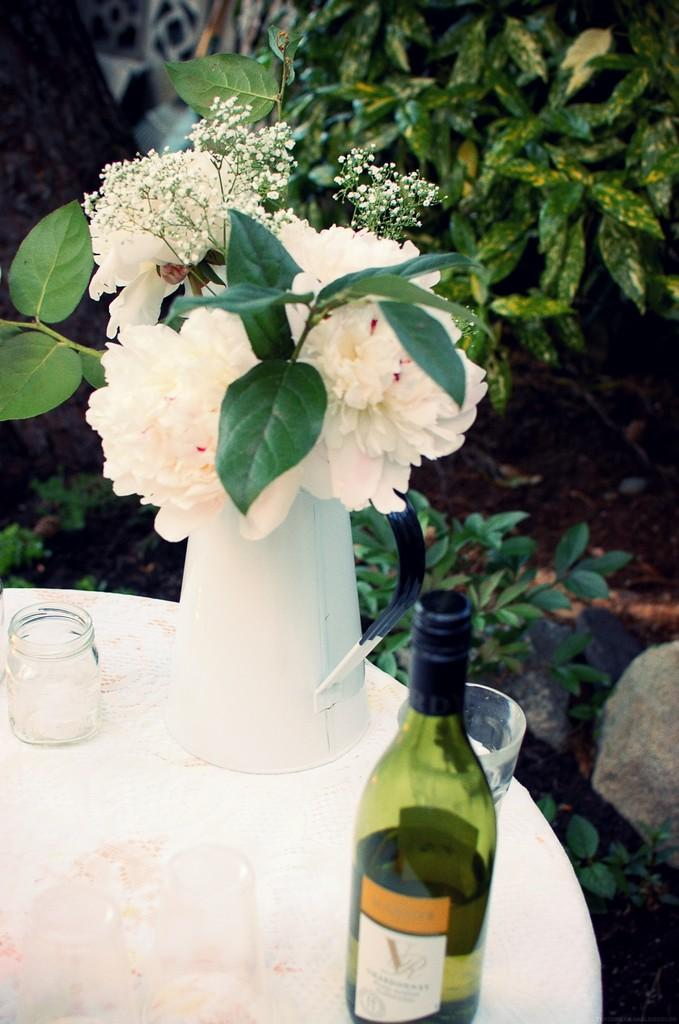What is on the table in the image? There is a flower vase, a jar, glasses, and a bottle on the table in the image. Can you describe the plant in the background of the image? There is a plant in the background of the image, but its specific characteristics are not mentioned in the provided facts. What type of container is the flower vase? The facts do not specify the type of container for the flower vase. What type of juice is being poured from the hydrant in the image? There is no hydrant or juice present in the image. Is there a bowl of lettuce on the table in the image? There is no mention of lettuce or a bowl in the image. 